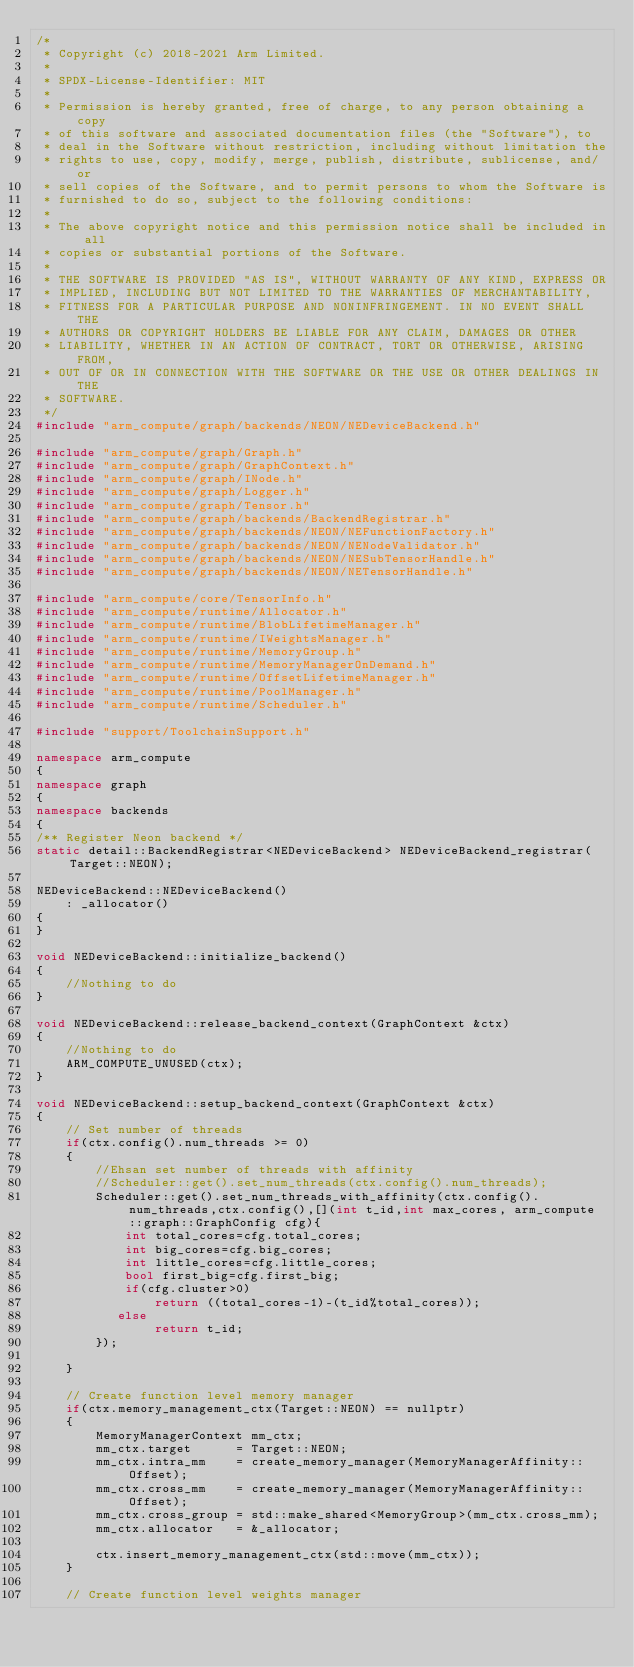<code> <loc_0><loc_0><loc_500><loc_500><_C++_>/*
 * Copyright (c) 2018-2021 Arm Limited.
 *
 * SPDX-License-Identifier: MIT
 *
 * Permission is hereby granted, free of charge, to any person obtaining a copy
 * of this software and associated documentation files (the "Software"), to
 * deal in the Software without restriction, including without limitation the
 * rights to use, copy, modify, merge, publish, distribute, sublicense, and/or
 * sell copies of the Software, and to permit persons to whom the Software is
 * furnished to do so, subject to the following conditions:
 *
 * The above copyright notice and this permission notice shall be included in all
 * copies or substantial portions of the Software.
 *
 * THE SOFTWARE IS PROVIDED "AS IS", WITHOUT WARRANTY OF ANY KIND, EXPRESS OR
 * IMPLIED, INCLUDING BUT NOT LIMITED TO THE WARRANTIES OF MERCHANTABILITY,
 * FITNESS FOR A PARTICULAR PURPOSE AND NONINFRINGEMENT. IN NO EVENT SHALL THE
 * AUTHORS OR COPYRIGHT HOLDERS BE LIABLE FOR ANY CLAIM, DAMAGES OR OTHER
 * LIABILITY, WHETHER IN AN ACTION OF CONTRACT, TORT OR OTHERWISE, ARISING FROM,
 * OUT OF OR IN CONNECTION WITH THE SOFTWARE OR THE USE OR OTHER DEALINGS IN THE
 * SOFTWARE.
 */
#include "arm_compute/graph/backends/NEON/NEDeviceBackend.h"

#include "arm_compute/graph/Graph.h"
#include "arm_compute/graph/GraphContext.h"
#include "arm_compute/graph/INode.h"
#include "arm_compute/graph/Logger.h"
#include "arm_compute/graph/Tensor.h"
#include "arm_compute/graph/backends/BackendRegistrar.h"
#include "arm_compute/graph/backends/NEON/NEFunctionFactory.h"
#include "arm_compute/graph/backends/NEON/NENodeValidator.h"
#include "arm_compute/graph/backends/NEON/NESubTensorHandle.h"
#include "arm_compute/graph/backends/NEON/NETensorHandle.h"

#include "arm_compute/core/TensorInfo.h"
#include "arm_compute/runtime/Allocator.h"
#include "arm_compute/runtime/BlobLifetimeManager.h"
#include "arm_compute/runtime/IWeightsManager.h"
#include "arm_compute/runtime/MemoryGroup.h"
#include "arm_compute/runtime/MemoryManagerOnDemand.h"
#include "arm_compute/runtime/OffsetLifetimeManager.h"
#include "arm_compute/runtime/PoolManager.h"
#include "arm_compute/runtime/Scheduler.h"

#include "support/ToolchainSupport.h"

namespace arm_compute
{
namespace graph
{
namespace backends
{
/** Register Neon backend */
static detail::BackendRegistrar<NEDeviceBackend> NEDeviceBackend_registrar(Target::NEON);

NEDeviceBackend::NEDeviceBackend()
    : _allocator()
{
}

void NEDeviceBackend::initialize_backend()
{
    //Nothing to do
}

void NEDeviceBackend::release_backend_context(GraphContext &ctx)
{
    //Nothing to do
    ARM_COMPUTE_UNUSED(ctx);
}

void NEDeviceBackend::setup_backend_context(GraphContext &ctx)
{
    // Set number of threads
    if(ctx.config().num_threads >= 0)
    {
    	//Ehsan set number of threads with affinity
        //Scheduler::get().set_num_threads(ctx.config().num_threads);
    	Scheduler::get().set_num_threads_with_affinity(ctx.config().num_threads,ctx.config(),[](int t_id,int max_cores, arm_compute::graph::GraphConfig cfg){
    		int total_cores=cfg.total_cores;
    		int big_cores=cfg.big_cores;
    		int little_cores=cfg.little_cores;
    		bool first_big=cfg.first_big;
    		if(cfg.cluster>0)
    			return ((total_cores-1)-(t_id%total_cores));
		   else
			    return t_id;
    	});

    }

    // Create function level memory manager
    if(ctx.memory_management_ctx(Target::NEON) == nullptr)
    {
        MemoryManagerContext mm_ctx;
        mm_ctx.target      = Target::NEON;
        mm_ctx.intra_mm    = create_memory_manager(MemoryManagerAffinity::Offset);
        mm_ctx.cross_mm    = create_memory_manager(MemoryManagerAffinity::Offset);
        mm_ctx.cross_group = std::make_shared<MemoryGroup>(mm_ctx.cross_mm);
        mm_ctx.allocator   = &_allocator;

        ctx.insert_memory_management_ctx(std::move(mm_ctx));
    }

    // Create function level weights manager</code> 